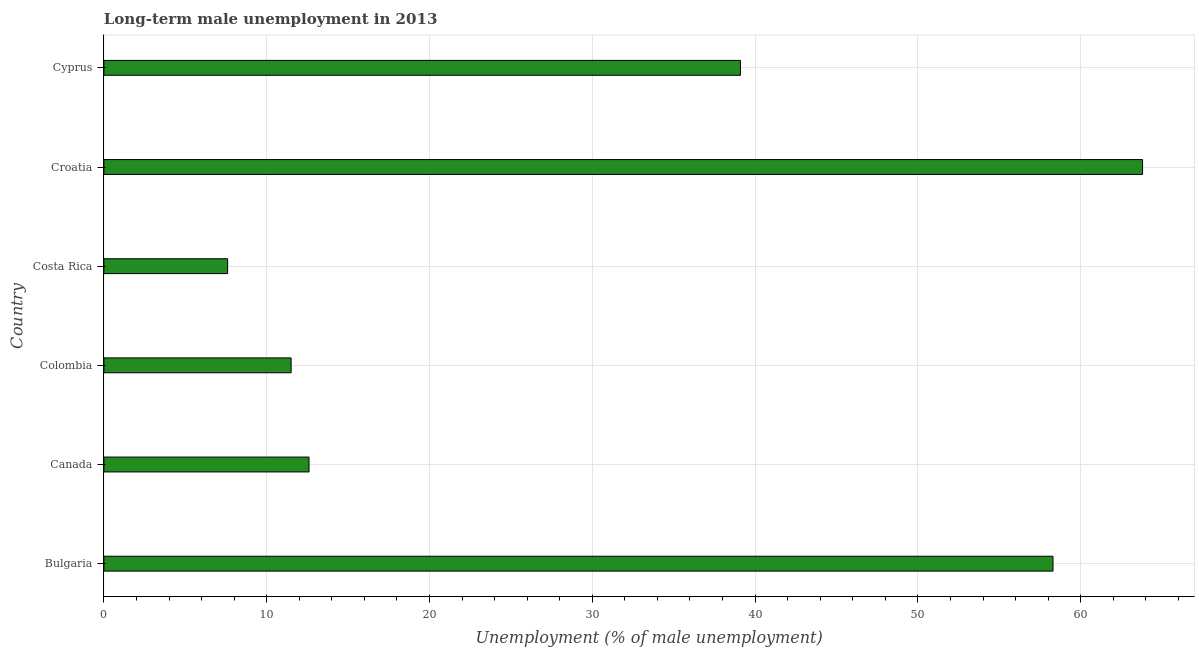What is the title of the graph?
Provide a short and direct response. Long-term male unemployment in 2013. What is the label or title of the X-axis?
Offer a terse response. Unemployment (% of male unemployment). What is the long-term male unemployment in Cyprus?
Ensure brevity in your answer.  39.1. Across all countries, what is the maximum long-term male unemployment?
Your answer should be compact. 63.8. Across all countries, what is the minimum long-term male unemployment?
Provide a succinct answer. 7.6. In which country was the long-term male unemployment maximum?
Provide a succinct answer. Croatia. In which country was the long-term male unemployment minimum?
Make the answer very short. Costa Rica. What is the sum of the long-term male unemployment?
Give a very brief answer. 192.9. What is the difference between the long-term male unemployment in Bulgaria and Canada?
Keep it short and to the point. 45.7. What is the average long-term male unemployment per country?
Ensure brevity in your answer.  32.15. What is the median long-term male unemployment?
Ensure brevity in your answer.  25.85. What is the ratio of the long-term male unemployment in Costa Rica to that in Cyprus?
Offer a terse response. 0.19. What is the difference between the highest and the second highest long-term male unemployment?
Offer a terse response. 5.5. What is the difference between the highest and the lowest long-term male unemployment?
Offer a very short reply. 56.2. In how many countries, is the long-term male unemployment greater than the average long-term male unemployment taken over all countries?
Provide a succinct answer. 3. Are all the bars in the graph horizontal?
Provide a short and direct response. Yes. What is the difference between two consecutive major ticks on the X-axis?
Provide a succinct answer. 10. Are the values on the major ticks of X-axis written in scientific E-notation?
Ensure brevity in your answer.  No. What is the Unemployment (% of male unemployment) in Bulgaria?
Your response must be concise. 58.3. What is the Unemployment (% of male unemployment) in Canada?
Your response must be concise. 12.6. What is the Unemployment (% of male unemployment) of Costa Rica?
Make the answer very short. 7.6. What is the Unemployment (% of male unemployment) in Croatia?
Your answer should be compact. 63.8. What is the Unemployment (% of male unemployment) in Cyprus?
Provide a succinct answer. 39.1. What is the difference between the Unemployment (% of male unemployment) in Bulgaria and Canada?
Keep it short and to the point. 45.7. What is the difference between the Unemployment (% of male unemployment) in Bulgaria and Colombia?
Ensure brevity in your answer.  46.8. What is the difference between the Unemployment (% of male unemployment) in Bulgaria and Costa Rica?
Give a very brief answer. 50.7. What is the difference between the Unemployment (% of male unemployment) in Bulgaria and Croatia?
Provide a short and direct response. -5.5. What is the difference between the Unemployment (% of male unemployment) in Bulgaria and Cyprus?
Your answer should be compact. 19.2. What is the difference between the Unemployment (% of male unemployment) in Canada and Colombia?
Keep it short and to the point. 1.1. What is the difference between the Unemployment (% of male unemployment) in Canada and Croatia?
Provide a succinct answer. -51.2. What is the difference between the Unemployment (% of male unemployment) in Canada and Cyprus?
Offer a terse response. -26.5. What is the difference between the Unemployment (% of male unemployment) in Colombia and Costa Rica?
Your response must be concise. 3.9. What is the difference between the Unemployment (% of male unemployment) in Colombia and Croatia?
Ensure brevity in your answer.  -52.3. What is the difference between the Unemployment (% of male unemployment) in Colombia and Cyprus?
Your response must be concise. -27.6. What is the difference between the Unemployment (% of male unemployment) in Costa Rica and Croatia?
Make the answer very short. -56.2. What is the difference between the Unemployment (% of male unemployment) in Costa Rica and Cyprus?
Keep it short and to the point. -31.5. What is the difference between the Unemployment (% of male unemployment) in Croatia and Cyprus?
Offer a very short reply. 24.7. What is the ratio of the Unemployment (% of male unemployment) in Bulgaria to that in Canada?
Make the answer very short. 4.63. What is the ratio of the Unemployment (% of male unemployment) in Bulgaria to that in Colombia?
Offer a terse response. 5.07. What is the ratio of the Unemployment (% of male unemployment) in Bulgaria to that in Costa Rica?
Provide a short and direct response. 7.67. What is the ratio of the Unemployment (% of male unemployment) in Bulgaria to that in Croatia?
Give a very brief answer. 0.91. What is the ratio of the Unemployment (% of male unemployment) in Bulgaria to that in Cyprus?
Offer a very short reply. 1.49. What is the ratio of the Unemployment (% of male unemployment) in Canada to that in Colombia?
Your response must be concise. 1.1. What is the ratio of the Unemployment (% of male unemployment) in Canada to that in Costa Rica?
Give a very brief answer. 1.66. What is the ratio of the Unemployment (% of male unemployment) in Canada to that in Croatia?
Your answer should be very brief. 0.2. What is the ratio of the Unemployment (% of male unemployment) in Canada to that in Cyprus?
Ensure brevity in your answer.  0.32. What is the ratio of the Unemployment (% of male unemployment) in Colombia to that in Costa Rica?
Ensure brevity in your answer.  1.51. What is the ratio of the Unemployment (% of male unemployment) in Colombia to that in Croatia?
Offer a very short reply. 0.18. What is the ratio of the Unemployment (% of male unemployment) in Colombia to that in Cyprus?
Your response must be concise. 0.29. What is the ratio of the Unemployment (% of male unemployment) in Costa Rica to that in Croatia?
Your answer should be very brief. 0.12. What is the ratio of the Unemployment (% of male unemployment) in Costa Rica to that in Cyprus?
Provide a short and direct response. 0.19. What is the ratio of the Unemployment (% of male unemployment) in Croatia to that in Cyprus?
Provide a short and direct response. 1.63. 